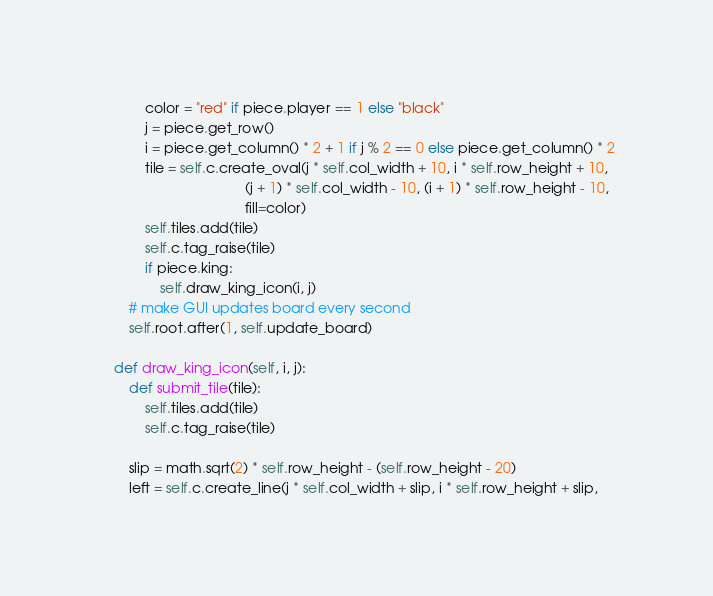<code> <loc_0><loc_0><loc_500><loc_500><_Python_>
            color = "red" if piece.player == 1 else "black"
            j = piece.get_row()
            i = piece.get_column() * 2 + 1 if j % 2 == 0 else piece.get_column() * 2
            tile = self.c.create_oval(j * self.col_width + 10, i * self.row_height + 10,
                                      (j + 1) * self.col_width - 10, (i + 1) * self.row_height - 10,
                                      fill=color)
            self.tiles.add(tile)
            self.c.tag_raise(tile)
            if piece.king:
                self.draw_king_icon(i, j)
        # make GUI updates board every second
        self.root.after(1, self.update_board)

    def draw_king_icon(self, i, j):
        def submit_tile(tile):
            self.tiles.add(tile)
            self.c.tag_raise(tile)

        slip = math.sqrt(2) * self.row_height - (self.row_height - 20)
        left = self.c.create_line(j * self.col_width + slip, i * self.row_height + slip,</code> 